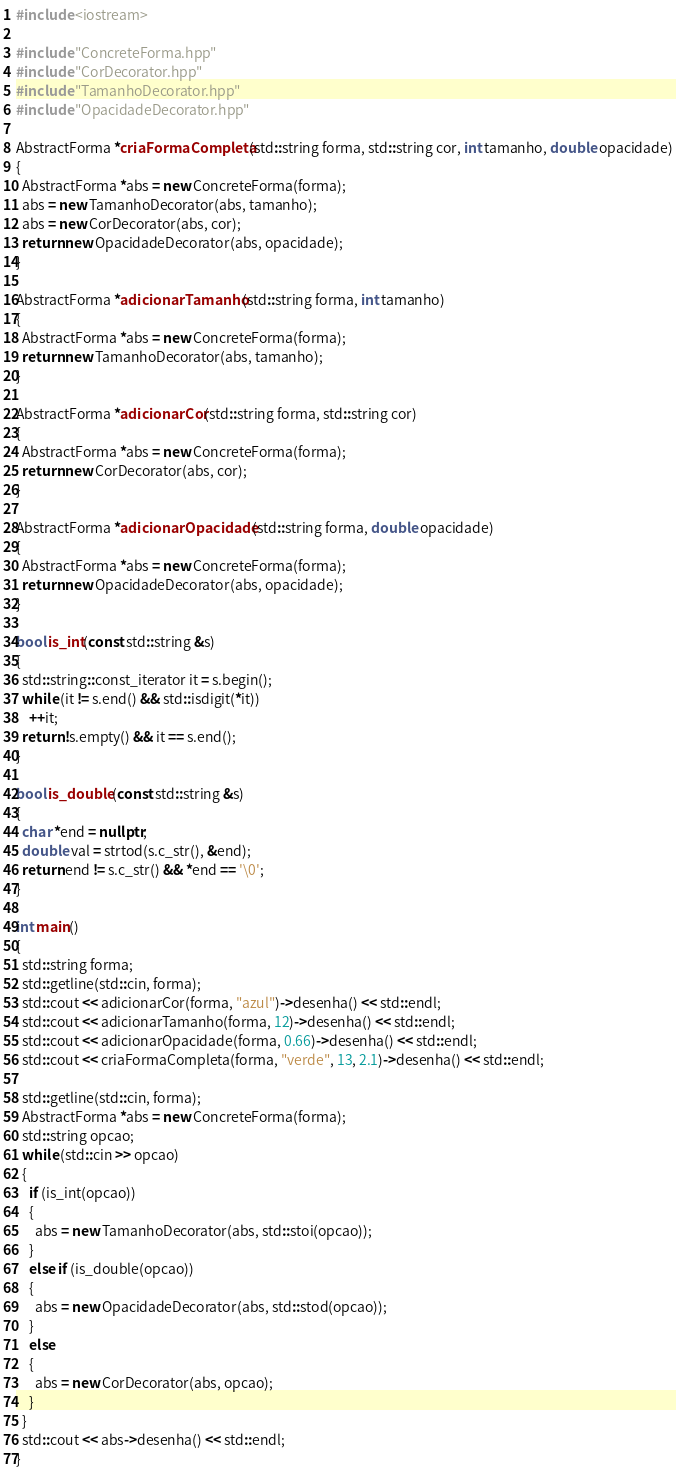Convert code to text. <code><loc_0><loc_0><loc_500><loc_500><_C++_>#include <iostream>

#include "ConcreteForma.hpp"
#include "CorDecorator.hpp"
#include "TamanhoDecorator.hpp"
#include "OpacidadeDecorator.hpp"

AbstractForma *criaFormaCompleta(std::string forma, std::string cor, int tamanho, double opacidade)
{
  AbstractForma *abs = new ConcreteForma(forma);
  abs = new TamanhoDecorator(abs, tamanho);
  abs = new CorDecorator(abs, cor);
  return new OpacidadeDecorator(abs, opacidade);
}

AbstractForma *adicionarTamanho(std::string forma, int tamanho)
{
  AbstractForma *abs = new ConcreteForma(forma);
  return new TamanhoDecorator(abs, tamanho);
}

AbstractForma *adicionarCor(std::string forma, std::string cor)
{
  AbstractForma *abs = new ConcreteForma(forma);
  return new CorDecorator(abs, cor);
}

AbstractForma *adicionarOpacidade(std::string forma, double opacidade)
{
  AbstractForma *abs = new ConcreteForma(forma);
  return new OpacidadeDecorator(abs, opacidade);
}

bool is_int(const std::string &s)
{
  std::string::const_iterator it = s.begin();
  while (it != s.end() && std::isdigit(*it))
    ++it;
  return !s.empty() && it == s.end();
}

bool is_double(const std::string &s)
{
  char *end = nullptr;
  double val = strtod(s.c_str(), &end);
  return end != s.c_str() && *end == '\0';
}

int main()
{
  std::string forma;
  std::getline(std::cin, forma);
  std::cout << adicionarCor(forma, "azul")->desenha() << std::endl;
  std::cout << adicionarTamanho(forma, 12)->desenha() << std::endl;
  std::cout << adicionarOpacidade(forma, 0.66)->desenha() << std::endl;
  std::cout << criaFormaCompleta(forma, "verde", 13, 2.1)->desenha() << std::endl;

  std::getline(std::cin, forma);
  AbstractForma *abs = new ConcreteForma(forma);
  std::string opcao;
  while (std::cin >> opcao)
  {
    if (is_int(opcao))
    {
      abs = new TamanhoDecorator(abs, std::stoi(opcao));
    }
    else if (is_double(opcao))
    {
      abs = new OpacidadeDecorator(abs, std::stod(opcao));
    }
    else
    {
      abs = new CorDecorator(abs, opcao);
    }
  }
  std::cout << abs->desenha() << std::endl;
}</code> 